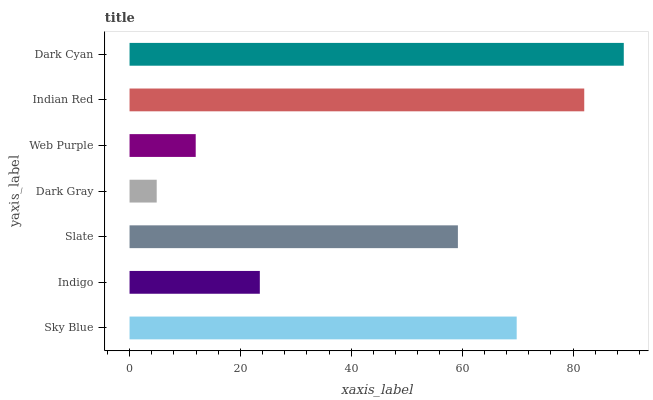Is Dark Gray the minimum?
Answer yes or no. Yes. Is Dark Cyan the maximum?
Answer yes or no. Yes. Is Indigo the minimum?
Answer yes or no. No. Is Indigo the maximum?
Answer yes or no. No. Is Sky Blue greater than Indigo?
Answer yes or no. Yes. Is Indigo less than Sky Blue?
Answer yes or no. Yes. Is Indigo greater than Sky Blue?
Answer yes or no. No. Is Sky Blue less than Indigo?
Answer yes or no. No. Is Slate the high median?
Answer yes or no. Yes. Is Slate the low median?
Answer yes or no. Yes. Is Indian Red the high median?
Answer yes or no. No. Is Sky Blue the low median?
Answer yes or no. No. 